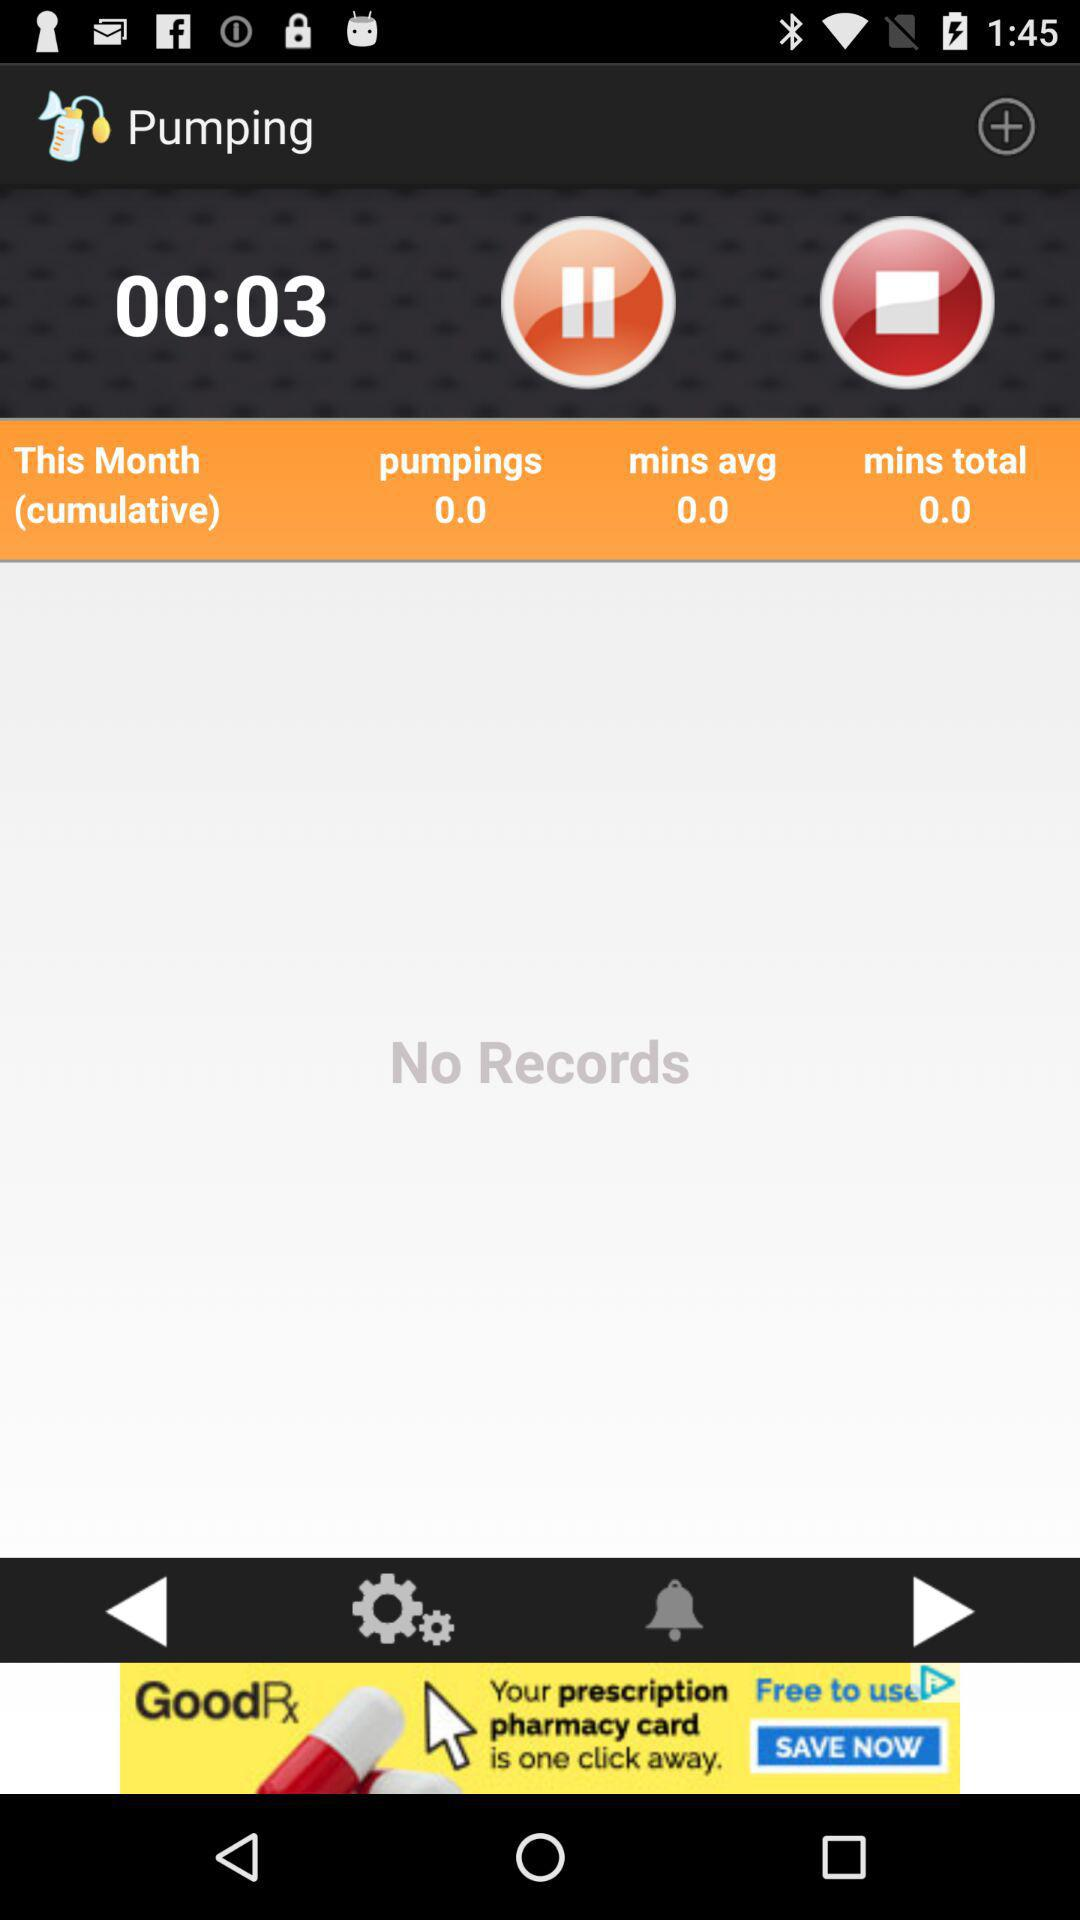What is the average number of minutes? The average number of minutes is 0. 